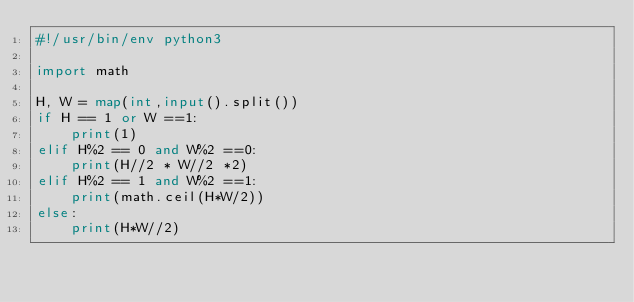Convert code to text. <code><loc_0><loc_0><loc_500><loc_500><_Python_>#!/usr/bin/env python3

import math

H, W = map(int,input().split())
if H == 1 or W ==1:
    print(1)
elif H%2 == 0 and W%2 ==0:
    print(H//2 * W//2 *2)
elif H%2 == 1 and W%2 ==1:
    print(math.ceil(H*W/2))
else:
    print(H*W//2)</code> 